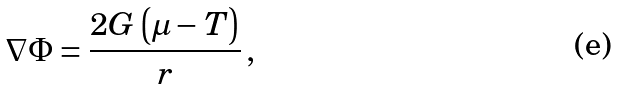Convert formula to latex. <formula><loc_0><loc_0><loc_500><loc_500>\nabla \Phi = \frac { 2 G \left ( \mu - T \right ) } { r } \, ,</formula> 